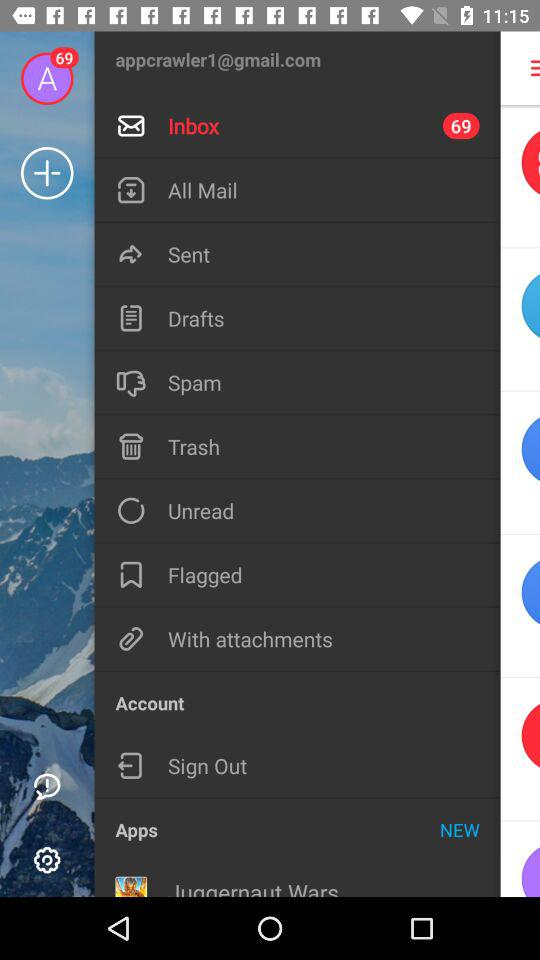What is the email address of the user? The email address of the user is appcrawler1@gmail.com. 